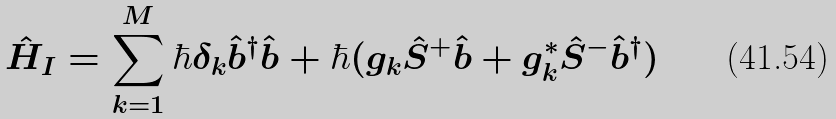Convert formula to latex. <formula><loc_0><loc_0><loc_500><loc_500>\hat { H } _ { I } = \sum _ { k = 1 } ^ { M } \hbar { \delta } _ { k } \hat { b } ^ { \dagger } \hat { b } + \hbar { ( } g _ { k } \hat { S } ^ { + } \hat { b } + g _ { k } ^ { * } \hat { S } ^ { - } \hat { b } ^ { \dagger } )</formula> 